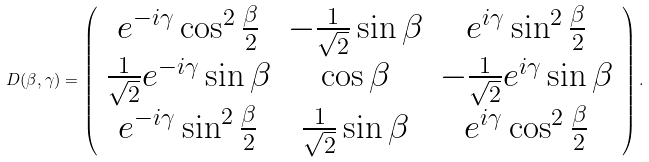<formula> <loc_0><loc_0><loc_500><loc_500>D ( \beta , \gamma ) = \left ( \begin{array} { c c c } { { e ^ { - i \gamma } \cos ^ { 2 } { \frac { \beta } { 2 } } } } & { { - \frac { 1 } { \sqrt { 2 } } \sin { \beta } } } & { { e ^ { i \gamma } \sin ^ { 2 } { \frac { \beta } { 2 } } } } \\ { { \frac { 1 } { \sqrt { 2 } } e ^ { - i \gamma } \sin { \beta } } } & { { \cos { \beta } } } & { { - \frac { 1 } { \sqrt { 2 } } e ^ { i \gamma } \sin { \beta } } } \\ { { e ^ { - i \gamma } \sin ^ { 2 } { \frac { \beta } { 2 } } } } & { { \frac { 1 } { \sqrt { 2 } } \sin { \beta } } } & { { e ^ { i \gamma } \cos ^ { 2 } { \frac { \beta } { 2 } } } } \end{array} \right ) .</formula> 